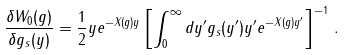Convert formula to latex. <formula><loc_0><loc_0><loc_500><loc_500>\frac { \delta W _ { 0 } ( g ) } { \delta g _ { s } ( y ) } = \frac { 1 } { 2 } y e ^ { - X ( g ) y } \left [ \int _ { 0 } ^ { \infty } d y ^ { \prime } g _ { s } ( y ^ { \prime } ) y ^ { \prime } e ^ { - X ( g ) y ^ { \prime } } \right ] ^ { - 1 } \, .</formula> 